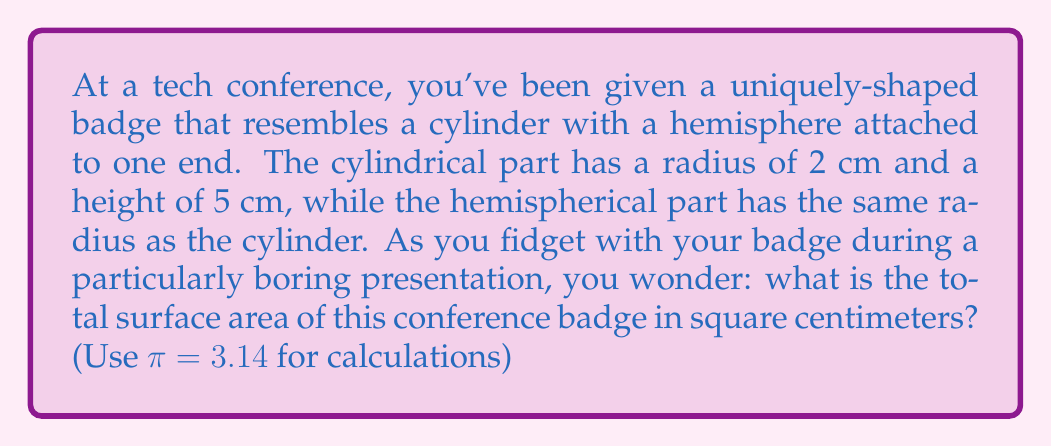What is the answer to this math problem? Let's break this down step-by-step:

1) The badge consists of two parts: a cylinder and a hemisphere.

2) For the cylinder:
   - Lateral surface area: $A_{lateral} = 2\pi rh$
   - One circular base: $A_{base} = \pi r^2$

3) For the hemisphere:
   - Surface area: $A_{hemisphere} = 2\pi r^2$

4) Calculate the cylinder's surface area:
   - Lateral surface area: $A_{lateral} = 2\pi (2)(5) = 20\pi$ cm²
   - One circular base: $A_{base} = \pi (2)^2 = 4\pi$ cm²
   - Total cylinder area: $A_{cylinder} = 20\pi + 4\pi = 24\pi$ cm²

5) Calculate the hemisphere's surface area:
   $A_{hemisphere} = 2\pi (2)^2 = 8\pi$ cm²

6) Total surface area:
   $A_{total} = A_{cylinder} + A_{hemisphere} = 24\pi + 8\pi = 32\pi$ cm²

7) Substitute $\pi = 3.14$:
   $A_{total} = 32(3.14) = 100.48$ cm²

[asy]
import three;

size(200);
currentprojection=perspective(6,3,2);

// Draw cylinder
draw(cylinder((0,0,0),2,5));

// Draw hemisphere
draw(shift(0,0,5)*surface(sphere(2),8S,8N));

// Labels
label("r=2cm",(2.5,0,2.5),E);
label("h=5cm",(0,2.5,2.5),N);
[/asy]
Answer: The total surface area of the conference badge is 100.48 cm². 